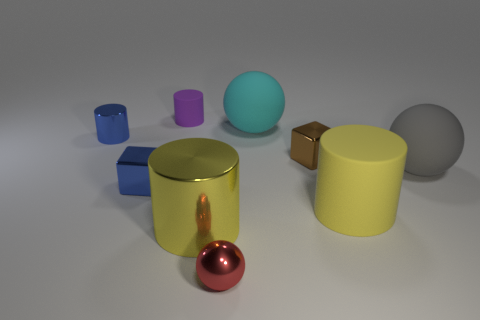What is the size of the brown cube?
Keep it short and to the point. Small. There is a block on the left side of the matte sphere on the left side of the cube right of the small matte cylinder; what is its color?
Offer a very short reply. Blue. Is the color of the rubber ball to the right of the brown cube the same as the shiny ball?
Provide a short and direct response. No. How many objects are both behind the red shiny sphere and in front of the small matte cylinder?
Your answer should be compact. 7. The yellow metal object that is the same shape as the tiny matte thing is what size?
Your answer should be very brief. Large. How many small purple cylinders are behind the big object that is behind the tiny metallic block that is to the right of the tiny blue metallic block?
Make the answer very short. 1. There is a metal block behind the sphere that is right of the big yellow matte object; what color is it?
Your response must be concise. Brown. What number of other objects are the same material as the big cyan thing?
Your answer should be very brief. 3. There is a metallic cube that is to the right of the purple thing; how many large spheres are to the right of it?
Your answer should be very brief. 1. Are there any other things that have the same shape as the big yellow metallic thing?
Provide a short and direct response. Yes. 